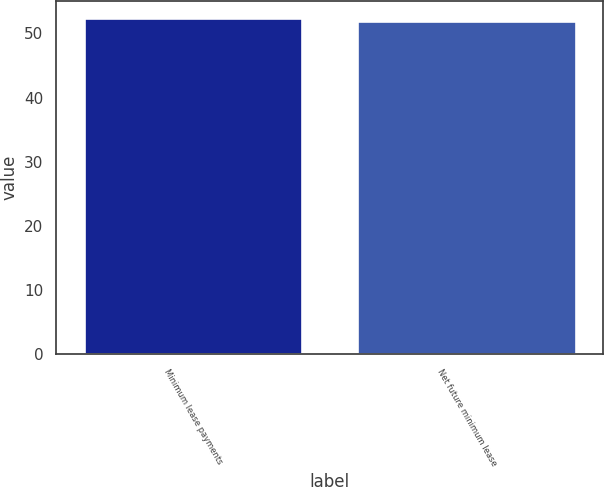Convert chart to OTSL. <chart><loc_0><loc_0><loc_500><loc_500><bar_chart><fcel>Minimum lease payments<fcel>Net future minimum lease<nl><fcel>52.4<fcel>51.9<nl></chart> 